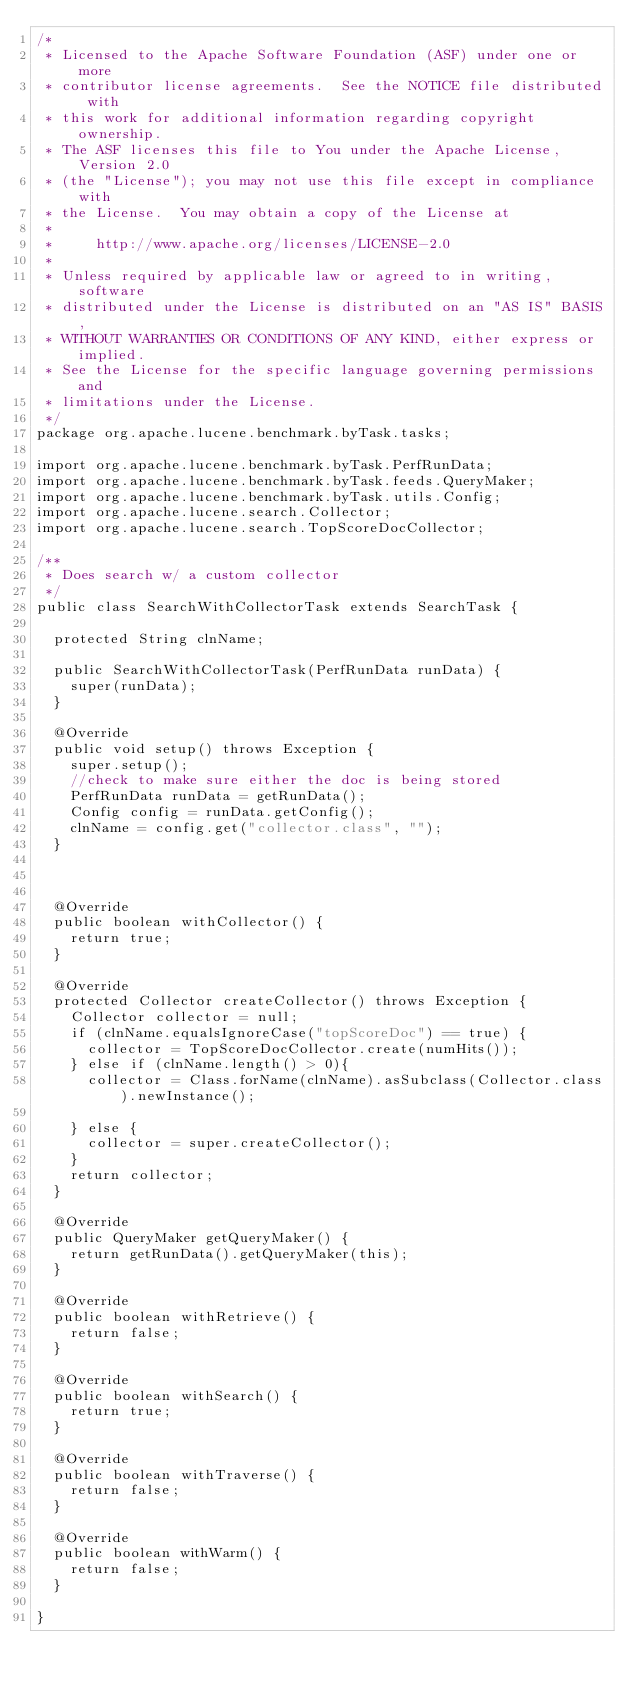<code> <loc_0><loc_0><loc_500><loc_500><_Java_>/*
 * Licensed to the Apache Software Foundation (ASF) under one or more
 * contributor license agreements.  See the NOTICE file distributed with
 * this work for additional information regarding copyright ownership.
 * The ASF licenses this file to You under the Apache License, Version 2.0
 * (the "License"); you may not use this file except in compliance with
 * the License.  You may obtain a copy of the License at
 *
 *     http://www.apache.org/licenses/LICENSE-2.0
 *
 * Unless required by applicable law or agreed to in writing, software
 * distributed under the License is distributed on an "AS IS" BASIS,
 * WITHOUT WARRANTIES OR CONDITIONS OF ANY KIND, either express or implied.
 * See the License for the specific language governing permissions and
 * limitations under the License.
 */
package org.apache.lucene.benchmark.byTask.tasks;

import org.apache.lucene.benchmark.byTask.PerfRunData;
import org.apache.lucene.benchmark.byTask.feeds.QueryMaker;
import org.apache.lucene.benchmark.byTask.utils.Config;
import org.apache.lucene.search.Collector;
import org.apache.lucene.search.TopScoreDocCollector;

/**
 * Does search w/ a custom collector
 */
public class SearchWithCollectorTask extends SearchTask {

  protected String clnName;

  public SearchWithCollectorTask(PerfRunData runData) {
    super(runData);
  }

  @Override
  public void setup() throws Exception {
    super.setup();
    //check to make sure either the doc is being stored
    PerfRunData runData = getRunData();
    Config config = runData.getConfig();
    clnName = config.get("collector.class", "");
  }

  

  @Override
  public boolean withCollector() {
    return true;
  }

  @Override
  protected Collector createCollector() throws Exception {
    Collector collector = null;
    if (clnName.equalsIgnoreCase("topScoreDoc") == true) {
      collector = TopScoreDocCollector.create(numHits());
    } else if (clnName.length() > 0){
      collector = Class.forName(clnName).asSubclass(Collector.class).newInstance();

    } else {
      collector = super.createCollector();
    }
    return collector;
  }

  @Override
  public QueryMaker getQueryMaker() {
    return getRunData().getQueryMaker(this);
  }

  @Override
  public boolean withRetrieve() {
    return false;
  }

  @Override
  public boolean withSearch() {
    return true;
  }

  @Override
  public boolean withTraverse() {
    return false;
  }

  @Override
  public boolean withWarm() {
    return false;
  }

}
</code> 